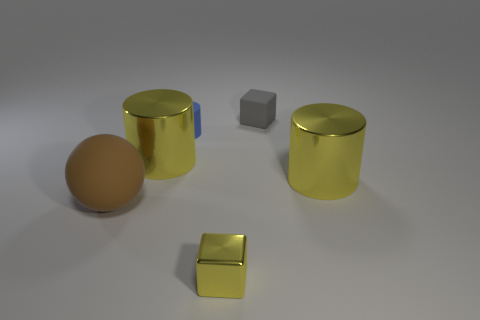Subtract all yellow metal cylinders. How many cylinders are left? 1 Add 1 red things. How many objects exist? 7 Subtract 1 spheres. How many spheres are left? 0 Subtract all blue cylinders. How many cylinders are left? 2 Subtract all spheres. How many objects are left? 5 Subtract all gray spheres. How many red cylinders are left? 0 Add 4 large cyan metal objects. How many large cyan metal objects exist? 4 Subtract 0 brown cylinders. How many objects are left? 6 Subtract all red blocks. Subtract all purple balls. How many blocks are left? 2 Subtract all tiny gray rubber things. Subtract all small rubber blocks. How many objects are left? 4 